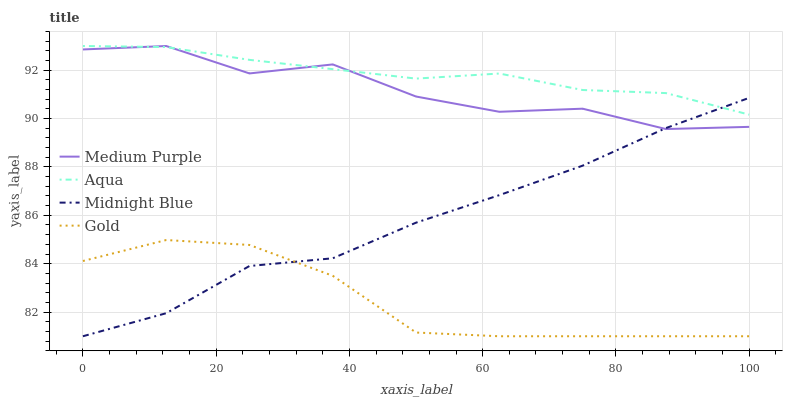Does Gold have the minimum area under the curve?
Answer yes or no. Yes. Does Aqua have the maximum area under the curve?
Answer yes or no. Yes. Does Midnight Blue have the minimum area under the curve?
Answer yes or no. No. Does Midnight Blue have the maximum area under the curve?
Answer yes or no. No. Is Aqua the smoothest?
Answer yes or no. Yes. Is Medium Purple the roughest?
Answer yes or no. Yes. Is Midnight Blue the smoothest?
Answer yes or no. No. Is Midnight Blue the roughest?
Answer yes or no. No. Does Midnight Blue have the lowest value?
Answer yes or no. Yes. Does Aqua have the lowest value?
Answer yes or no. No. Does Aqua have the highest value?
Answer yes or no. Yes. Does Midnight Blue have the highest value?
Answer yes or no. No. Is Gold less than Aqua?
Answer yes or no. Yes. Is Aqua greater than Gold?
Answer yes or no. Yes. Does Medium Purple intersect Aqua?
Answer yes or no. Yes. Is Medium Purple less than Aqua?
Answer yes or no. No. Is Medium Purple greater than Aqua?
Answer yes or no. No. Does Gold intersect Aqua?
Answer yes or no. No. 